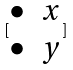<formula> <loc_0><loc_0><loc_500><loc_500>[ \begin{matrix} \bullet & x \\ \bullet & y \end{matrix} ]</formula> 